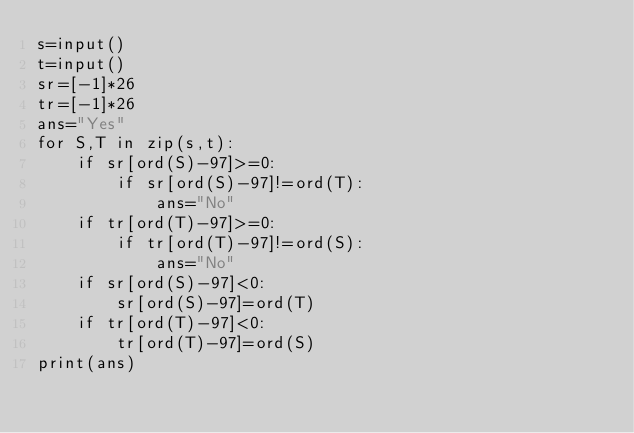Convert code to text. <code><loc_0><loc_0><loc_500><loc_500><_Python_>s=input()
t=input()
sr=[-1]*26
tr=[-1]*26
ans="Yes"
for S,T in zip(s,t):
    if sr[ord(S)-97]>=0:
        if sr[ord(S)-97]!=ord(T):
            ans="No"
    if tr[ord(T)-97]>=0:
        if tr[ord(T)-97]!=ord(S):
            ans="No"
    if sr[ord(S)-97]<0:
        sr[ord(S)-97]=ord(T)
    if tr[ord(T)-97]<0:
        tr[ord(T)-97]=ord(S)
print(ans)</code> 